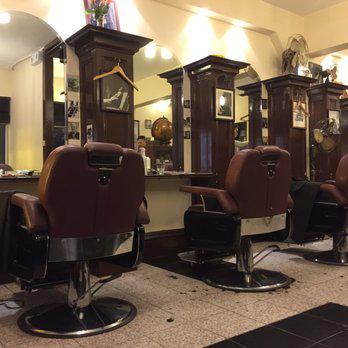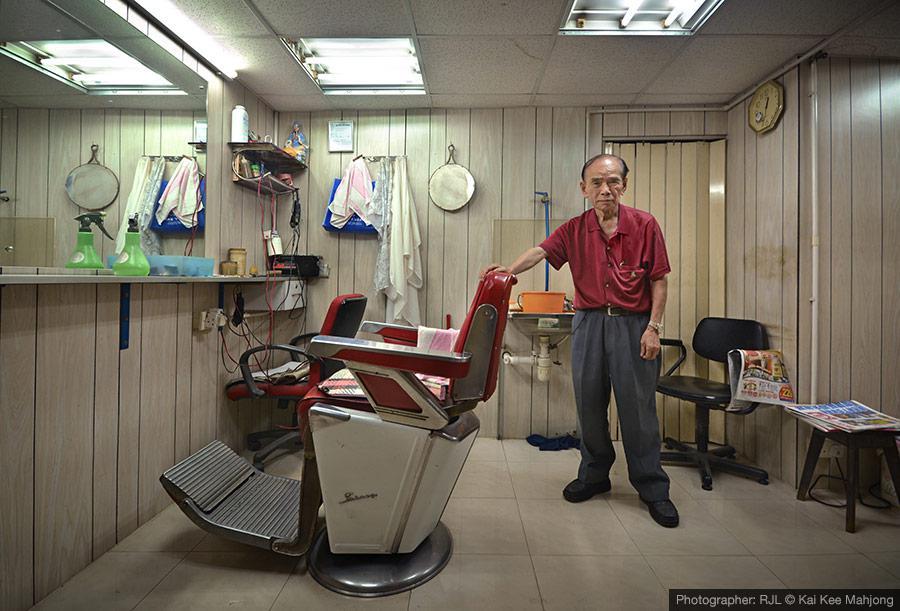The first image is the image on the left, the second image is the image on the right. Examine the images to the left and right. Is the description "There are at least two bright red chairs." accurate? Answer yes or no. Yes. The first image is the image on the left, the second image is the image on the right. Given the left and right images, does the statement "Both rooms are empty." hold true? Answer yes or no. No. 